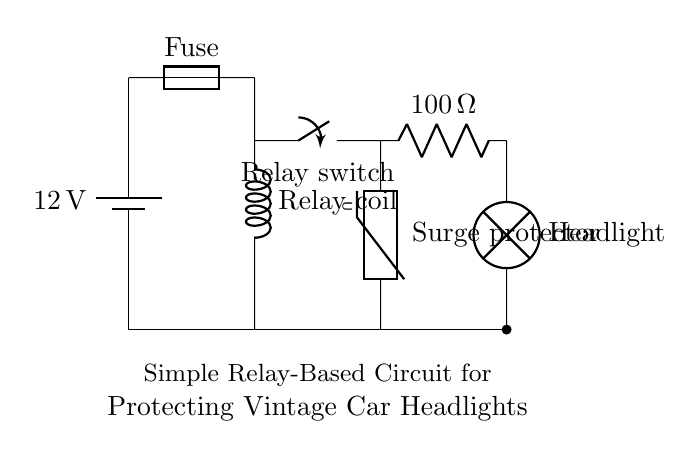What is the voltage of the battery? The circuit shows a battery labeled with a voltage of 12 volts, indicating the potential difference provided by the battery. This is typically the standard voltage for automotive applications.
Answer: 12 volts What component protects the headlights from surges? The surge protector is specifically designed to limit the voltage provided to the headlights, preventing potential damage from power surges. The diagram indicates this component with the label "Surge protector."
Answer: Surge protector What is the resistance value in the circuit? The circuit features a resistor with a specified value of 100 ohms, which is indicated next to the resistor symbol in the diagram. This component helps limit the current in the circuit to protect other components.
Answer: 100 ohms How is the relay activated in this circuit? The relay coil is connected to the battery and is activated when current flows through it. The switch then closes to power the headlights. The functioning of the relay is initiated by the current through the coil, completing the circuit.
Answer: By the current through the relay coil What is the purpose of the fuse in this circuit? The fuse is a safety device that protects the circuit by blowing if the current exceeds a safe limit, preventing damage to the components. The label on the diagram clearly identifies it as a fuse.
Answer: To protect the circuit from excess current What happens if there is a power surge in the circuit? If a power surge occurs, the surge protector will engage, clamping the voltage to a safe level and thus protecting the headlights from damage caused by overvoltage. This function is indicated by the role of the surge protector in the circuit.
Answer: The surge protector engages 